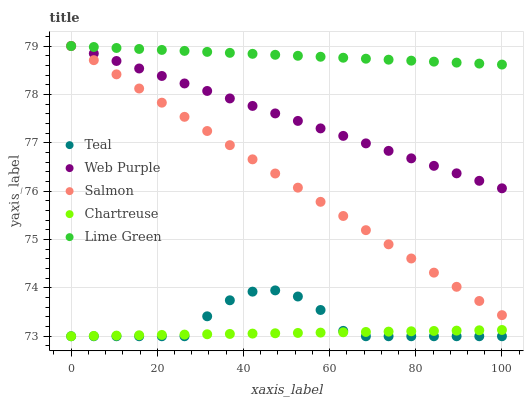Does Chartreuse have the minimum area under the curve?
Answer yes or no. Yes. Does Lime Green have the maximum area under the curve?
Answer yes or no. Yes. Does Web Purple have the minimum area under the curve?
Answer yes or no. No. Does Web Purple have the maximum area under the curve?
Answer yes or no. No. Is Lime Green the smoothest?
Answer yes or no. Yes. Is Teal the roughest?
Answer yes or no. Yes. Is Web Purple the smoothest?
Answer yes or no. No. Is Web Purple the roughest?
Answer yes or no. No. Does Chartreuse have the lowest value?
Answer yes or no. Yes. Does Web Purple have the lowest value?
Answer yes or no. No. Does Salmon have the highest value?
Answer yes or no. Yes. Does Chartreuse have the highest value?
Answer yes or no. No. Is Chartreuse less than Web Purple?
Answer yes or no. Yes. Is Lime Green greater than Chartreuse?
Answer yes or no. Yes. Does Chartreuse intersect Teal?
Answer yes or no. Yes. Is Chartreuse less than Teal?
Answer yes or no. No. Is Chartreuse greater than Teal?
Answer yes or no. No. Does Chartreuse intersect Web Purple?
Answer yes or no. No. 